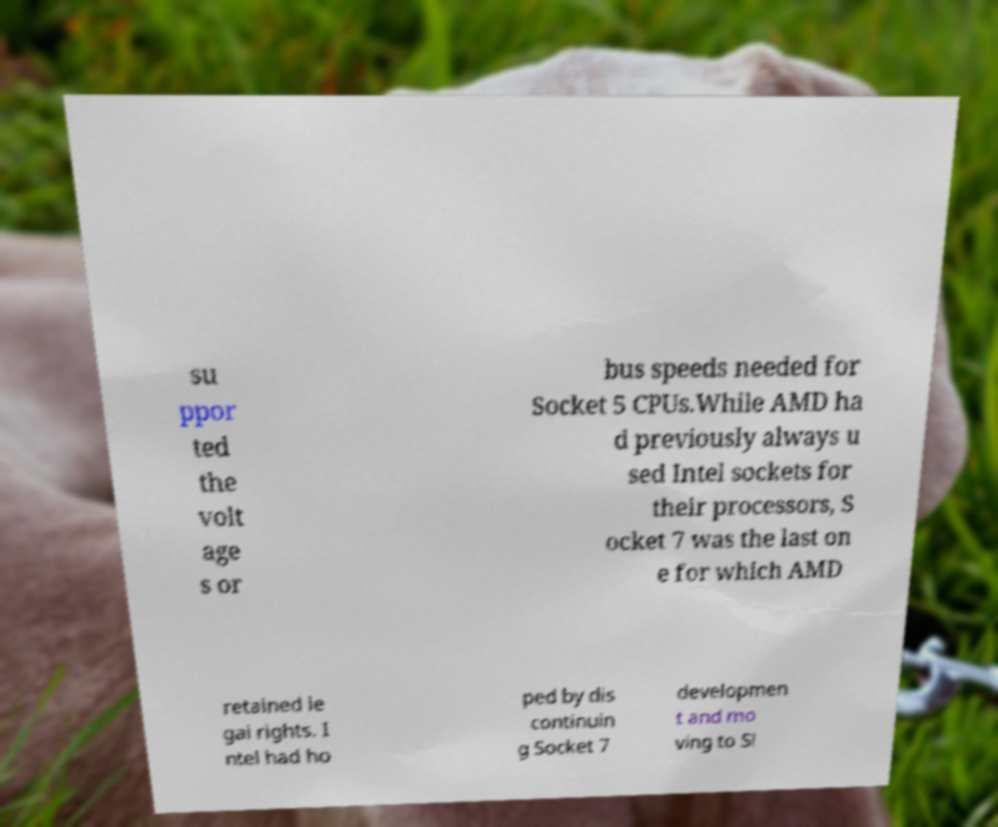For documentation purposes, I need the text within this image transcribed. Could you provide that? su ppor ted the volt age s or bus speeds needed for Socket 5 CPUs.While AMD ha d previously always u sed Intel sockets for their processors, S ocket 7 was the last on e for which AMD retained le gal rights. I ntel had ho ped by dis continuin g Socket 7 developmen t and mo ving to Sl 